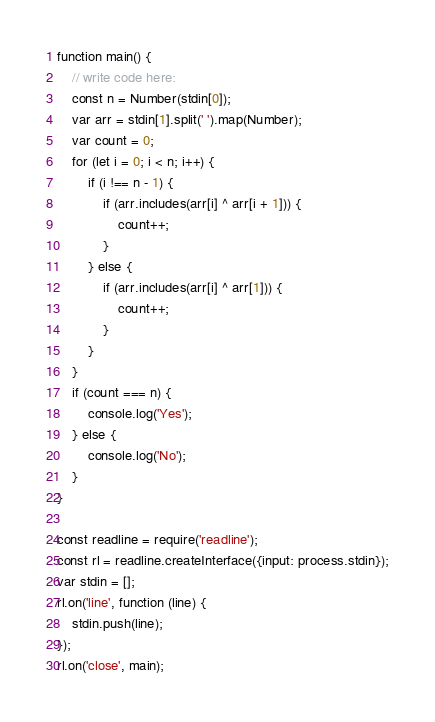Convert code to text. <code><loc_0><loc_0><loc_500><loc_500><_JavaScript_>function main() {
    // write code here:
    const n = Number(stdin[0]);
    var arr = stdin[1].split(' ').map(Number);
    var count = 0;
    for (let i = 0; i < n; i++) {
        if (i !== n - 1) {
            if (arr.includes(arr[i] ^ arr[i + 1])) {
                count++;
            }
        } else {
            if (arr.includes(arr[i] ^ arr[1])) {
                count++;
            }
        }
    }
    if (count === n) {
        console.log('Yes');
    } else {
        console.log('No');
    }
}

const readline = require('readline');
const rl = readline.createInterface({input: process.stdin});
var stdin = [];
rl.on('line', function (line) {
    stdin.push(line);
});
rl.on('close', main);</code> 